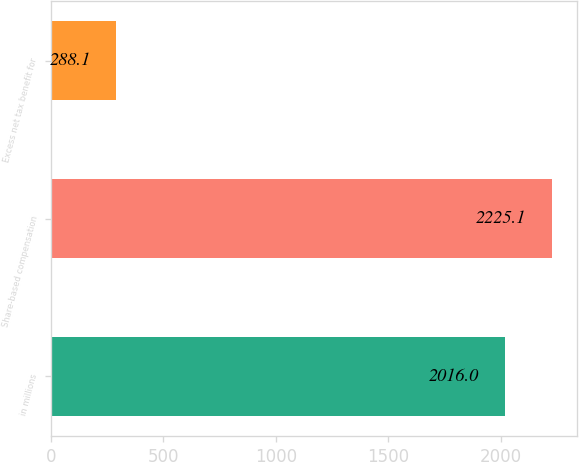Convert chart to OTSL. <chart><loc_0><loc_0><loc_500><loc_500><bar_chart><fcel>in millions<fcel>Share-based compensation<fcel>Excess net tax benefit for<nl><fcel>2016<fcel>2225.1<fcel>288.1<nl></chart> 